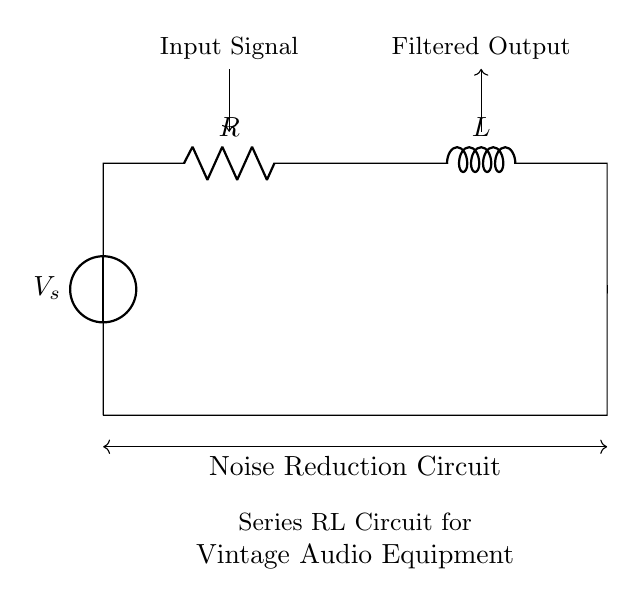What are the components of the circuit? The circuit consists of a voltage source, a resistor, and an inductor. These are visually identifiable from their standard symbols in the diagram.
Answer: Voltage source, resistor, inductor What is the function of the resistor in this circuit? The resistor is used to manage the current flow and dissipate power, helping to control noise levels in the audio equipment. Its placement indicates that it works together with the inductor to filter out unwanted noise.
Answer: Current control What is the output of the circuit? The output is the filtered signal, as indicated by the arrow pointing from the output node to the right, usually representing a cleaner audio signal post filtration.
Answer: Filtered output What is the purpose of the series RL circuit in audio applications? A series RL circuit is often employed in audio systems to attenuate high-frequency noise while allowing the desired audio signal to pass through efficiently. This is crucial for maintaining sound quality in vintage equipment.
Answer: Noise reduction What happens to the signal as it passes through the inductor? As the signal passes through the inductor, high-frequency components of the noise are impeded due to inductive reactance, which allows the lower frequency audio signal to be transmitted more effectively.
Answer: High-frequency attenuation How is the input signal connected in the circuit? The input signal is connected directly to the voltage source, which powers the entire circuit and allows the audio signal to enter the filter constructed by the resistor and inductor.
Answer: Connected to source What is the expected behavior of the circuit under load? Under load, the circuit should maintain audio quality by effectively reducing unwanted noise, ensuring that the output maintains fidelity despite varying input conditions or load impedance.
Answer: Maintains audio quality 